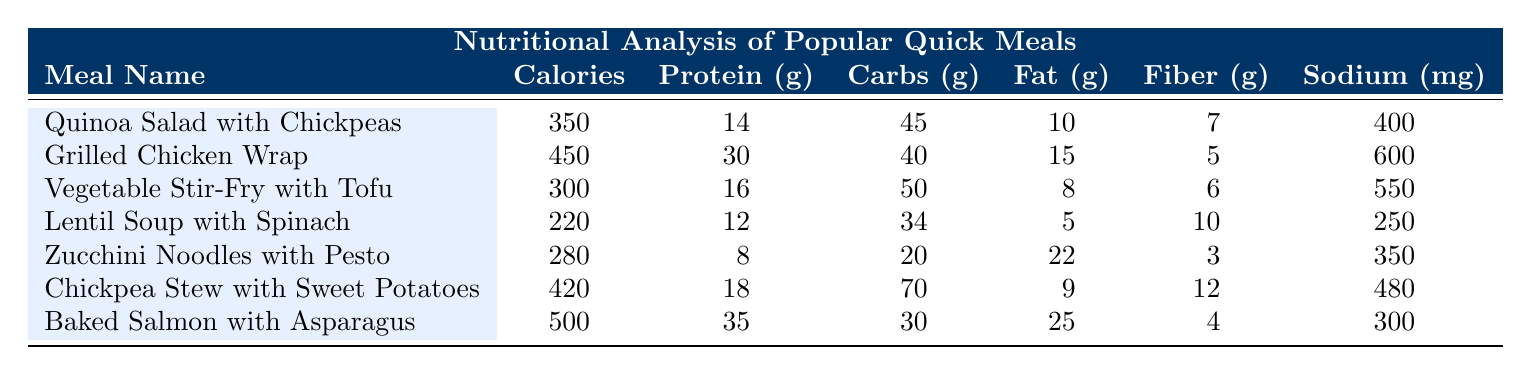What is the meal with the highest protein content? The meal with the highest protein content can be found by comparing the protein values of all the meals in the table. The "Baked Salmon with Asparagus" has 35 grams of protein, which is higher than all other meals listed.
Answer: Baked Salmon with Asparagus What is the total amount of carbohydrates in the "Chickpea Stew with Sweet Potatoes" and "Quinoa Salad with Chickpeas"? To find the total carbohydrates in these two meals, add their carbohydrates together: 70 grams (Chickpea Stew) + 45 grams (Quinoa Salad) = 115 grams.
Answer: 115 grams Does "Lentil Soup with Spinach" have more calories than "Zucchini Noodles with Pesto"? Comparing the calories in "Lentil Soup with Spinach" (220 calories) with "Zucchini Noodles with Pesto" (280 calories), the soup has fewer calories. Therefore, the statement is false.
Answer: No What is the average fat content of all the meals? To find the average fat content, we first sum the fat values: 10 + 15 + 8 + 5 + 22 + 9 + 25 = 94 grams. There are 7 meals, so we divide the total by 7: 94 / 7 ≈ 13.43 grams.
Answer: 13.43 grams Which meal has the least sodium, and what is its sodium content? The meal with the least sodium can be identified by examining the sodium values. "Lentil Soup with Spinach" has the lowest sodium at 250 mg, which is less than the sodium in all other meals.
Answer: Lentil Soup with Spinach, 250 mg What are the total calories of the two meals with the lowest calorie counts? The two meals with the lowest calorie counts are "Lentil Soup with Spinach" (220 calories) and "Zucchini Noodles with Pesto" (280 calories). Adding these gives 220 + 280 = 500 calories.
Answer: 500 calories Is the "Grilled Chicken Wrap" higher in both protein and fat than "Chickpea Stew with Sweet Potatoes"? The "Grilled Chicken Wrap" has 30 grams of protein and 15 grams of fat, while "Chickpea Stew" has 18 grams of protein and 9 grams of fat. Both comparisons show that the wrap has more of both components, confirming the statement is true.
Answer: Yes What is the difference in fiber content between "Baked Salmon with Asparagus" and "Vegetable Stir-Fry with Tofu"? The fiber content of "Baked Salmon with Asparagus" is 4 grams and that of "Vegetable Stir-Fry with Tofu" is 6 grams. To find the difference, subtract: 6 - 4 = 2 grams.
Answer: 2 grams 